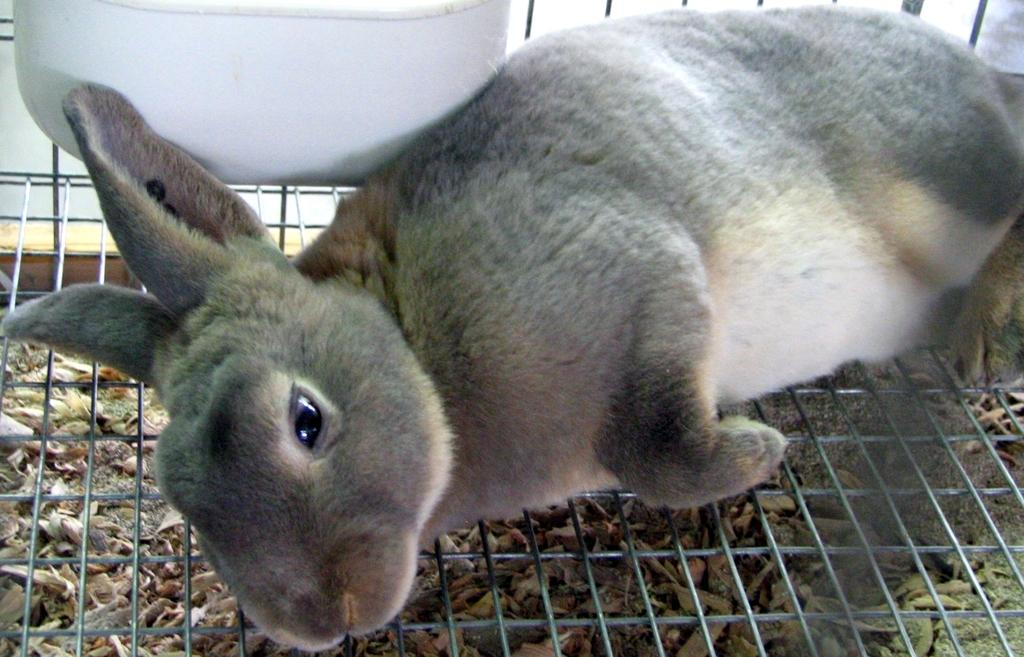What animal is in the image? There is a rabbit in the image. What is the rabbit lying on? The rabbit is lying on a welded wire. What object is located next to the rabbit? There is an object next to the rabbit, but its description is not provided in the facts. What type of material is present on the ground under the rabbit? Small wooden pieces are present on the ground under the rabbit. What invention does the rabbit use to turn the pages of a book in the image? There is no book or invention present in the image; it only features a rabbit lying on a welded wire with small wooden pieces on the ground. 